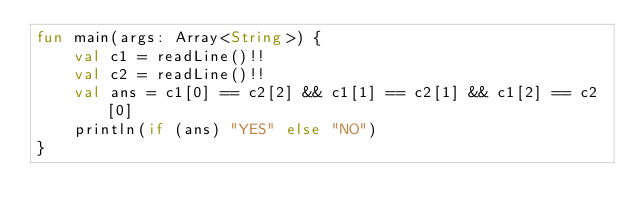<code> <loc_0><loc_0><loc_500><loc_500><_Kotlin_>fun main(args: Array<String>) {
    val c1 = readLine()!!
    val c2 = readLine()!!
    val ans = c1[0] == c2[2] && c1[1] == c2[1] && c1[2] == c2[0]
    println(if (ans) "YES" else "NO")
}
</code> 